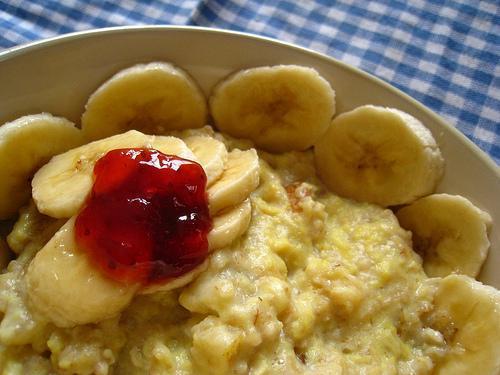How many scoops of jam are pictured?
Give a very brief answer. 1. 